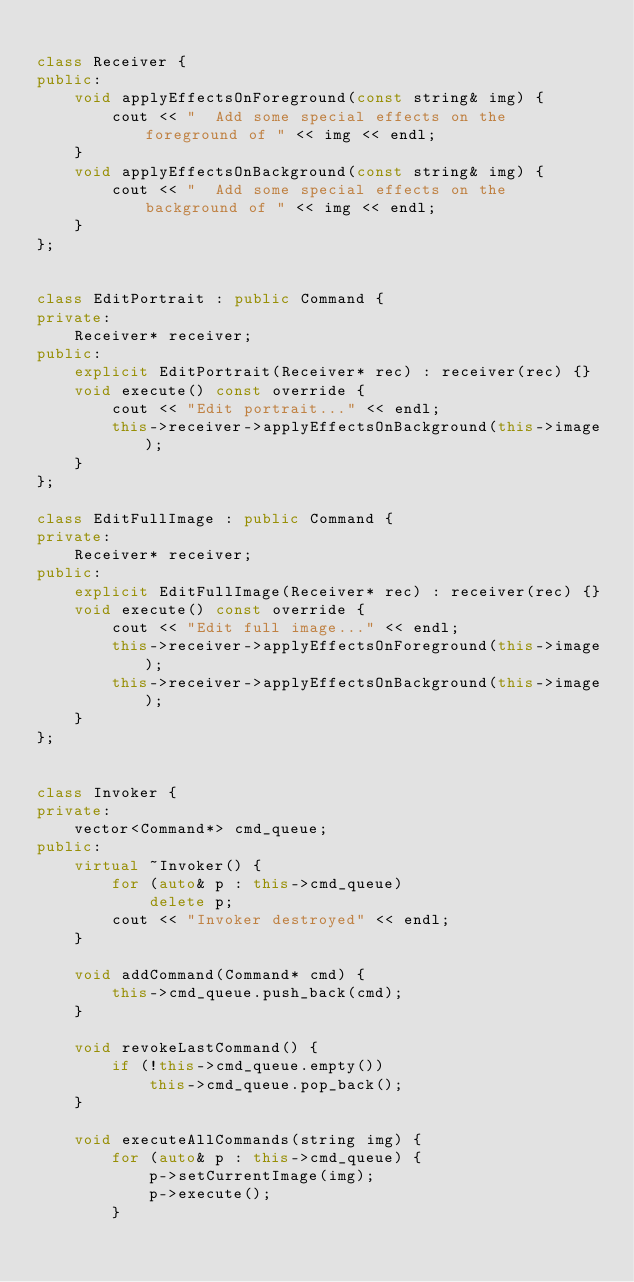<code> <loc_0><loc_0><loc_500><loc_500><_C++_>
class Receiver {
public:
    void applyEffectsOnForeground(const string& img) {
        cout << "  Add some special effects on the foreground of " << img << endl;
    }
    void applyEffectsOnBackground(const string& img) {
        cout << "  Add some special effects on the background of " << img << endl;
    }
};


class EditPortrait : public Command {
private:
    Receiver* receiver;
public:
    explicit EditPortrait(Receiver* rec) : receiver(rec) {}
    void execute() const override {
        cout << "Edit portrait..." << endl;
        this->receiver->applyEffectsOnBackground(this->image);
    }
};

class EditFullImage : public Command {
private:
    Receiver* receiver;
public:
    explicit EditFullImage(Receiver* rec) : receiver(rec) {}
    void execute() const override {
        cout << "Edit full image..." << endl;
        this->receiver->applyEffectsOnForeground(this->image);
        this->receiver->applyEffectsOnBackground(this->image);
    }
};


class Invoker {
private:
    vector<Command*> cmd_queue;
public:
    virtual ~Invoker() {
        for (auto& p : this->cmd_queue)
            delete p;
        cout << "Invoker destroyed" << endl;
    }

    void addCommand(Command* cmd) {
        this->cmd_queue.push_back(cmd);
    }

    void revokeLastCommand() {
        if (!this->cmd_queue.empty())
            this->cmd_queue.pop_back();
    }

    void executeAllCommands(string img) {
        for (auto& p : this->cmd_queue) {
            p->setCurrentImage(img);
            p->execute();
        }</code> 